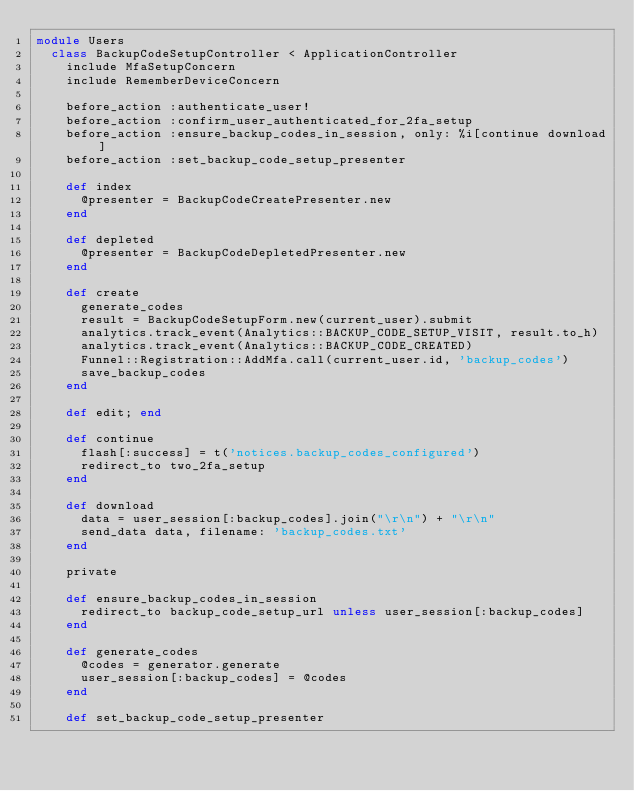<code> <loc_0><loc_0><loc_500><loc_500><_Ruby_>module Users
  class BackupCodeSetupController < ApplicationController
    include MfaSetupConcern
    include RememberDeviceConcern

    before_action :authenticate_user!
    before_action :confirm_user_authenticated_for_2fa_setup
    before_action :ensure_backup_codes_in_session, only: %i[continue download]
    before_action :set_backup_code_setup_presenter

    def index
      @presenter = BackupCodeCreatePresenter.new
    end

    def depleted
      @presenter = BackupCodeDepletedPresenter.new
    end

    def create
      generate_codes
      result = BackupCodeSetupForm.new(current_user).submit
      analytics.track_event(Analytics::BACKUP_CODE_SETUP_VISIT, result.to_h)
      analytics.track_event(Analytics::BACKUP_CODE_CREATED)
      Funnel::Registration::AddMfa.call(current_user.id, 'backup_codes')
      save_backup_codes
    end

    def edit; end

    def continue
      flash[:success] = t('notices.backup_codes_configured')
      redirect_to two_2fa_setup
    end

    def download
      data = user_session[:backup_codes].join("\r\n") + "\r\n"
      send_data data, filename: 'backup_codes.txt'
    end

    private

    def ensure_backup_codes_in_session
      redirect_to backup_code_setup_url unless user_session[:backup_codes]
    end

    def generate_codes
      @codes = generator.generate
      user_session[:backup_codes] = @codes
    end

    def set_backup_code_setup_presenter</code> 